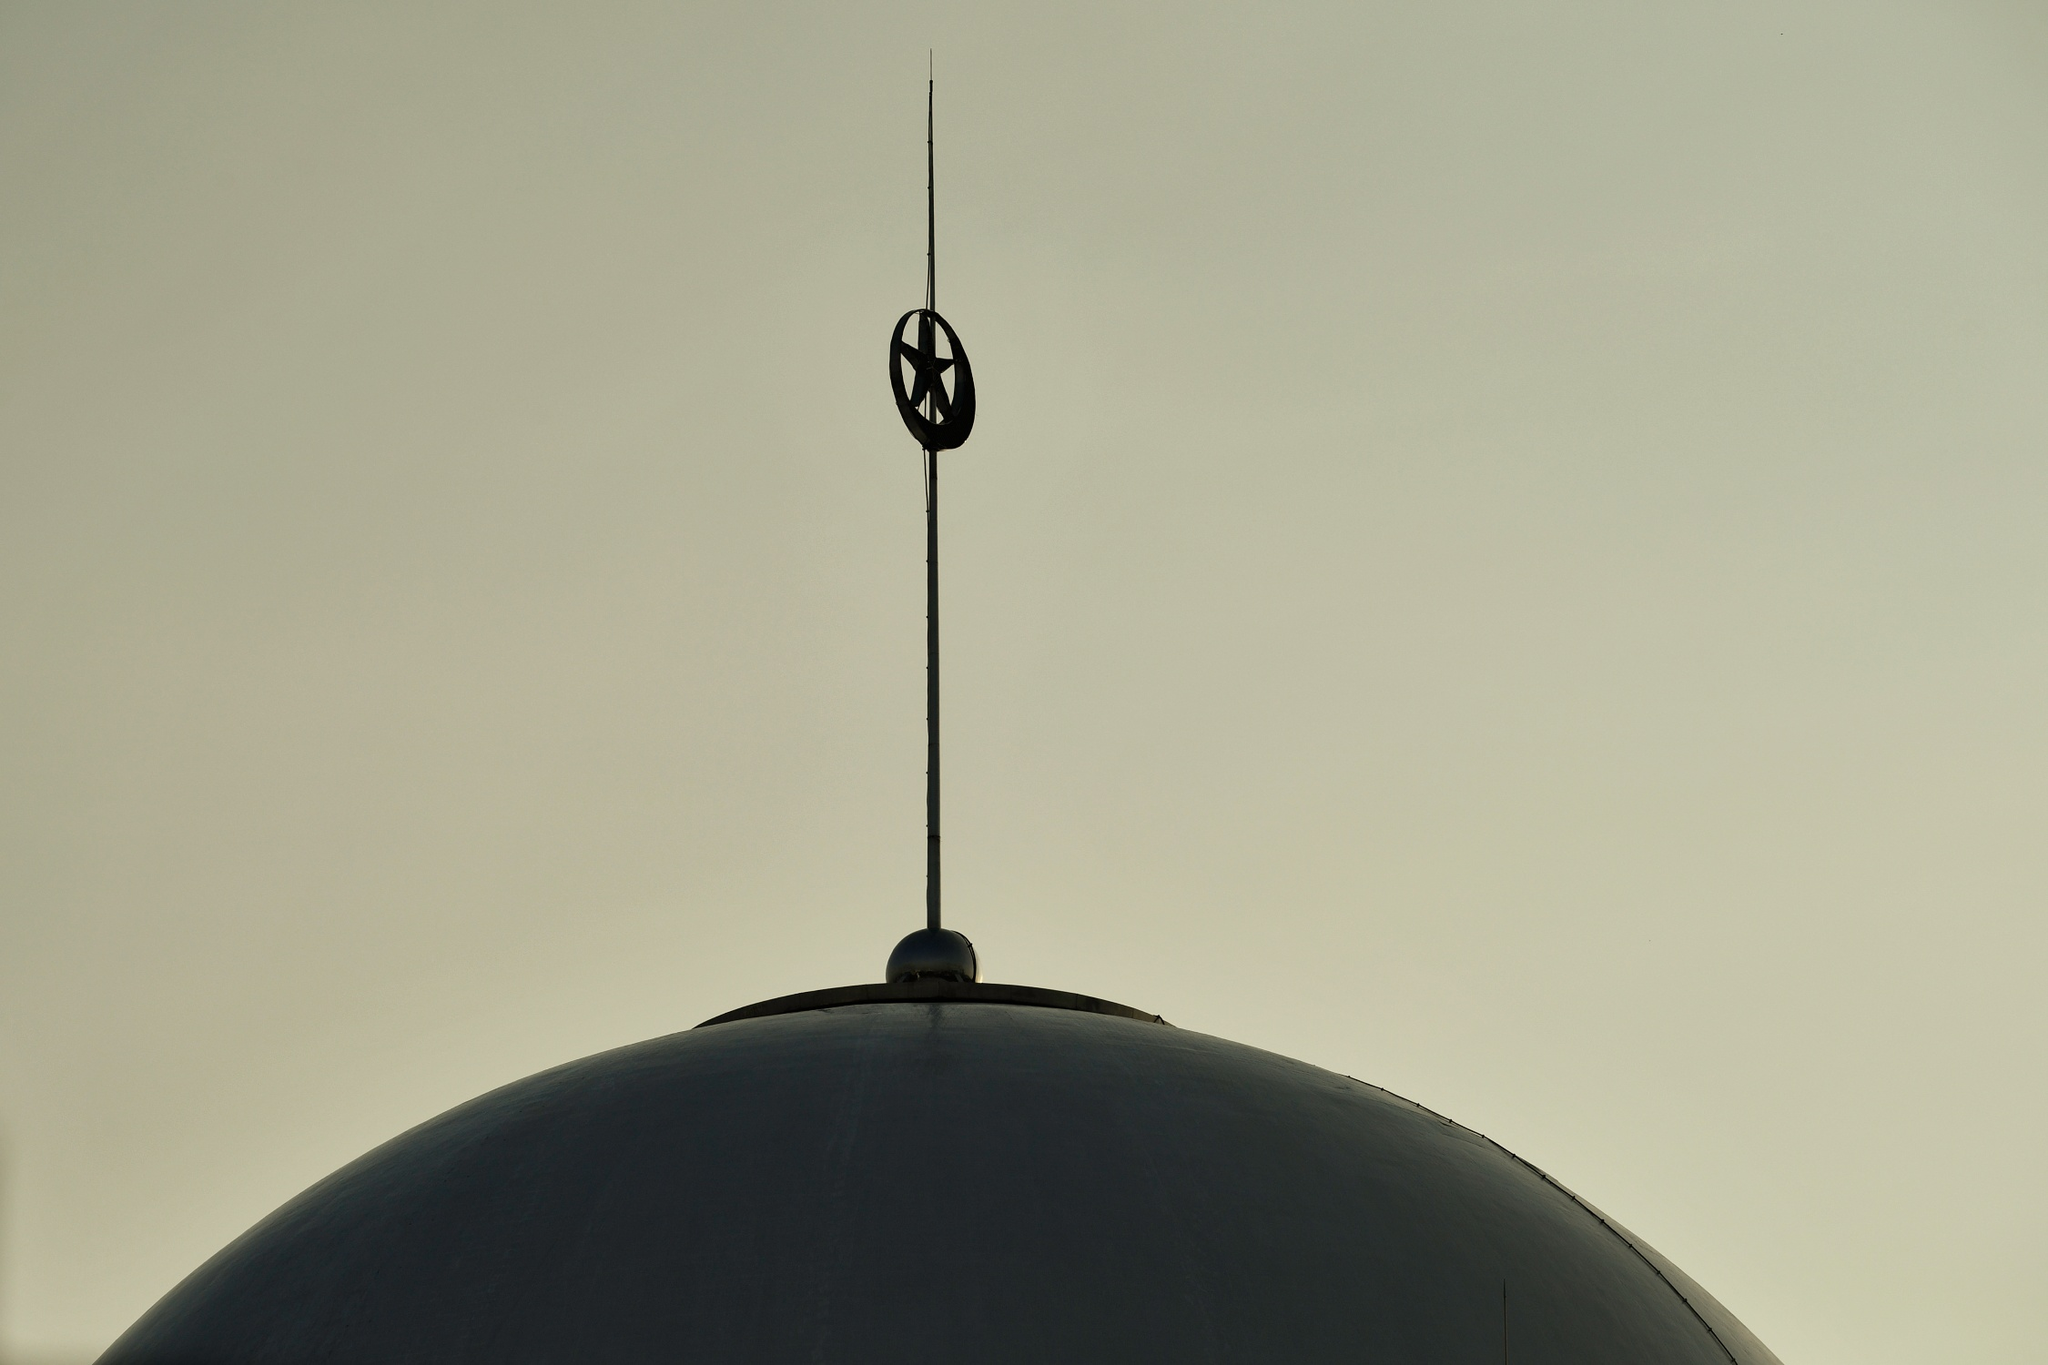How does the lighting in this image affect its mood or interpretation? The subdued lighting in the image casts the dome and spire in silhouette, creating a dramatic and somewhat mysterious atmosphere. This chiaroscuro effect accentuates the outline of the structure, inviting the viewer to focus on the shape and form of the architectural elements without the distraction of color or texture. The mood is contemplative and serene, allowing for personal interpretation and reflection on the symbolism and design of the structure. 